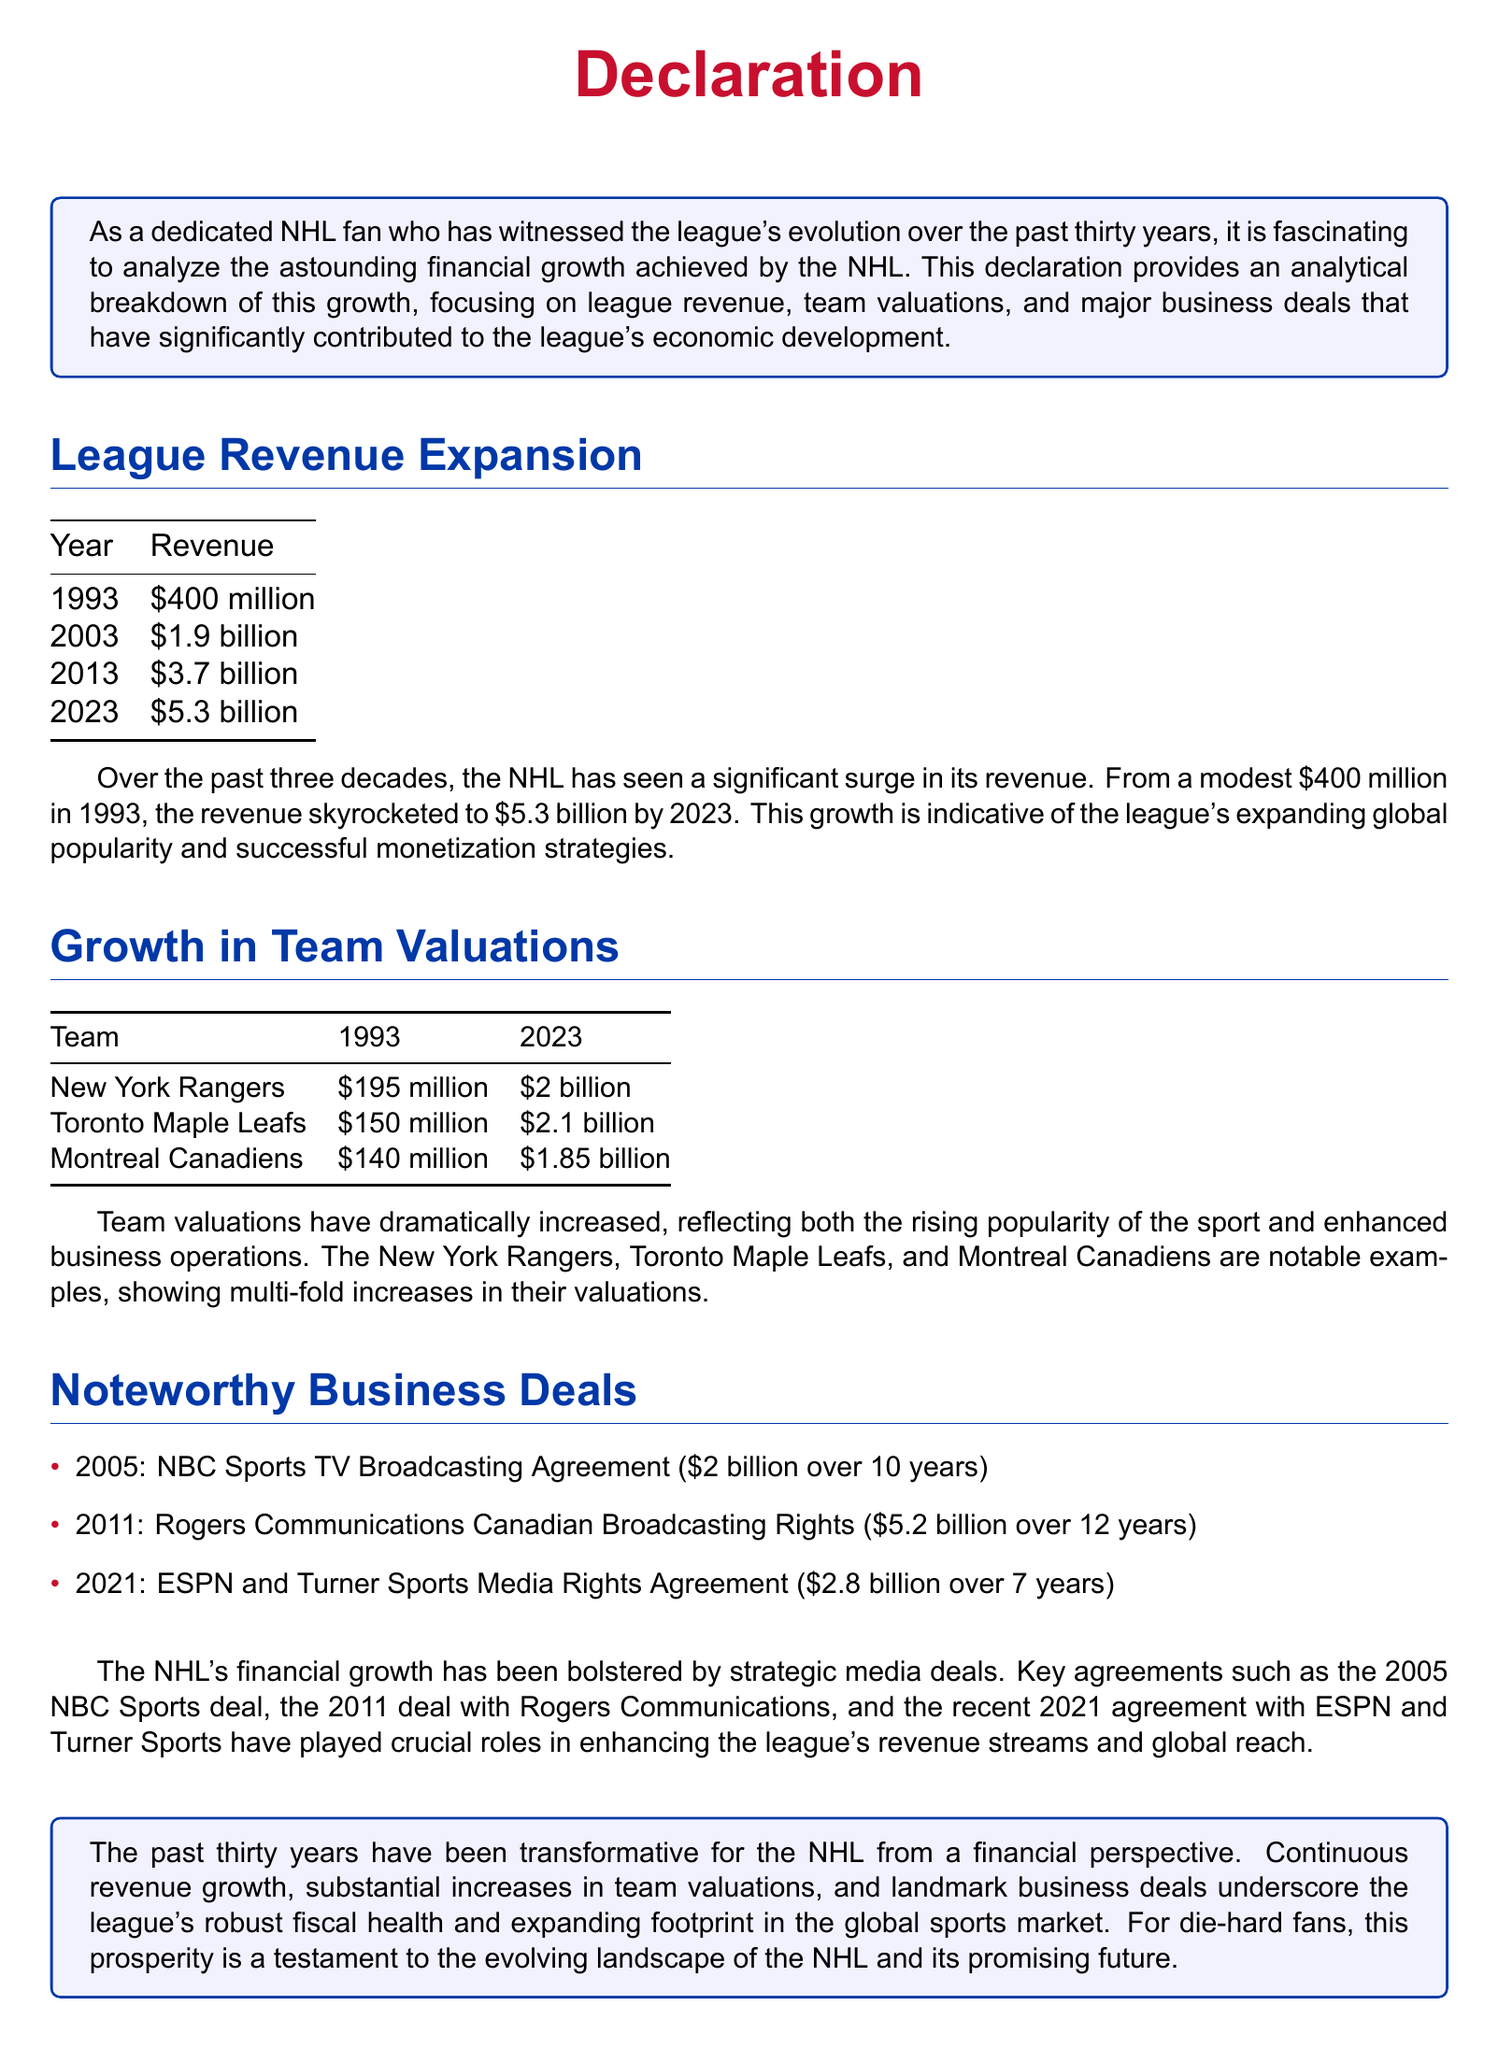what was the NHL's revenue in 1993? The revenue for the NHL in 1993 is explicitly listed in the document as $400 million.
Answer: $400 million what is the NHL's revenue in 2023? The document states that the NHL's revenue reached $5.3 billion in 2023.
Answer: $5.3 billion how much did the New York Rangers value increase from 1993 to 2023? The valuation increased from $195 million to $2 billion, which is a difference of $1.805 billion.
Answer: $1.805 billion which media rights agreement was made in 2011? The 2011 agreements with Rogers Communications are detailed in the document as the Canadian Broadcasting Rights.
Answer: Rogers Communications how many years was the NBC Sports TV broadcasting agreement? It specifies in the document that the NBC Sports agreement was for 10 years.
Answer: 10 years which team had a valuation of $150 million in 1993? The document clearly states that the Toronto Maple Leafs had that valuation in 1993.
Answer: Toronto Maple Leafs what was the total revenue in 2013? According to the document, the total revenue for the NHL in 2013 was $3.7 billion.
Answer: $3.7 billion what significant business deal was made in 2021? The document mentions the ESPN and Turner Sports Media Rights Agreement as the notable deal from 2021.
Answer: ESPN and Turner Sports which team was valued at $2.1 billion in 2023? The Toronto Maple Leafs are stated in the document as having that valuation in 2023.
Answer: Toronto Maple Leafs 